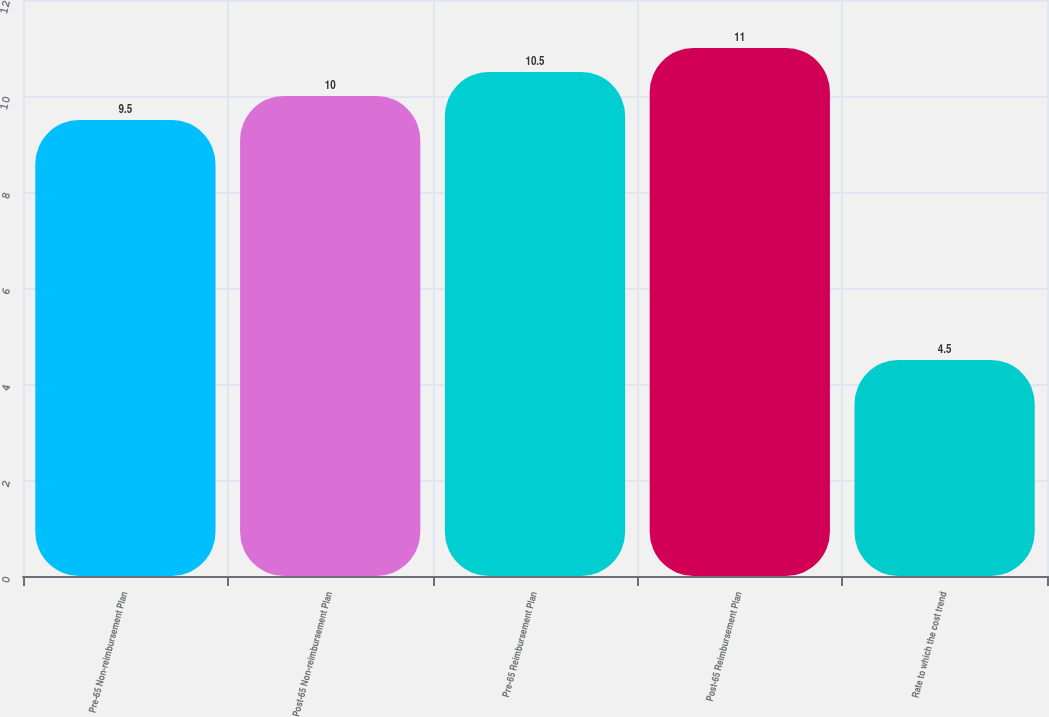Convert chart to OTSL. <chart><loc_0><loc_0><loc_500><loc_500><bar_chart><fcel>Pre-65 Non-reimbursement Plan<fcel>Post-65 Non-reimbursement Plan<fcel>Pre-65 Reimbursement Plan<fcel>Post-65 Reimbursement Plan<fcel>Rate to which the cost trend<nl><fcel>9.5<fcel>10<fcel>10.5<fcel>11<fcel>4.5<nl></chart> 